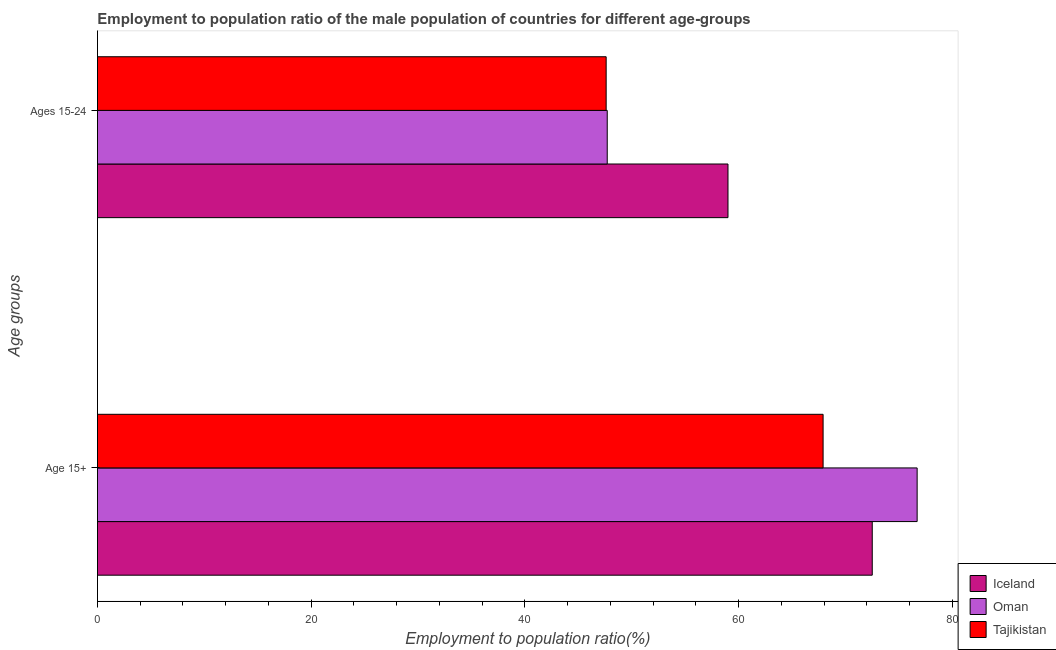How many groups of bars are there?
Offer a terse response. 2. How many bars are there on the 2nd tick from the top?
Give a very brief answer. 3. What is the label of the 2nd group of bars from the top?
Your answer should be compact. Age 15+. What is the employment to population ratio(age 15+) in Oman?
Give a very brief answer. 76.7. Across all countries, what is the minimum employment to population ratio(age 15-24)?
Offer a very short reply. 47.6. In which country was the employment to population ratio(age 15-24) maximum?
Your answer should be compact. Iceland. In which country was the employment to population ratio(age 15-24) minimum?
Make the answer very short. Tajikistan. What is the total employment to population ratio(age 15+) in the graph?
Provide a succinct answer. 217.1. What is the difference between the employment to population ratio(age 15-24) in Oman and that in Tajikistan?
Make the answer very short. 0.1. What is the difference between the employment to population ratio(age 15-24) in Tajikistan and the employment to population ratio(age 15+) in Iceland?
Give a very brief answer. -24.9. What is the average employment to population ratio(age 15+) per country?
Offer a terse response. 72.37. What is the difference between the employment to population ratio(age 15-24) and employment to population ratio(age 15+) in Oman?
Provide a short and direct response. -29. In how many countries, is the employment to population ratio(age 15-24) greater than 4 %?
Keep it short and to the point. 3. What is the ratio of the employment to population ratio(age 15-24) in Oman to that in Iceland?
Ensure brevity in your answer.  0.81. Is the employment to population ratio(age 15-24) in Iceland less than that in Tajikistan?
Offer a very short reply. No. In how many countries, is the employment to population ratio(age 15-24) greater than the average employment to population ratio(age 15-24) taken over all countries?
Offer a very short reply. 1. What does the 2nd bar from the top in Ages 15-24 represents?
Keep it short and to the point. Oman. What does the 3rd bar from the bottom in Ages 15-24 represents?
Make the answer very short. Tajikistan. How many bars are there?
Offer a very short reply. 6. Are all the bars in the graph horizontal?
Your answer should be compact. Yes. How many countries are there in the graph?
Keep it short and to the point. 3. Does the graph contain any zero values?
Make the answer very short. No. Does the graph contain grids?
Your answer should be compact. No. Where does the legend appear in the graph?
Offer a terse response. Bottom right. How are the legend labels stacked?
Make the answer very short. Vertical. What is the title of the graph?
Give a very brief answer. Employment to population ratio of the male population of countries for different age-groups. Does "Mexico" appear as one of the legend labels in the graph?
Your response must be concise. No. What is the label or title of the Y-axis?
Your answer should be compact. Age groups. What is the Employment to population ratio(%) in Iceland in Age 15+?
Ensure brevity in your answer.  72.5. What is the Employment to population ratio(%) in Oman in Age 15+?
Keep it short and to the point. 76.7. What is the Employment to population ratio(%) in Tajikistan in Age 15+?
Offer a very short reply. 67.9. What is the Employment to population ratio(%) of Oman in Ages 15-24?
Your answer should be compact. 47.7. What is the Employment to population ratio(%) of Tajikistan in Ages 15-24?
Your response must be concise. 47.6. Across all Age groups, what is the maximum Employment to population ratio(%) of Iceland?
Your answer should be compact. 72.5. Across all Age groups, what is the maximum Employment to population ratio(%) in Oman?
Your answer should be compact. 76.7. Across all Age groups, what is the maximum Employment to population ratio(%) in Tajikistan?
Your answer should be compact. 67.9. Across all Age groups, what is the minimum Employment to population ratio(%) of Oman?
Provide a succinct answer. 47.7. Across all Age groups, what is the minimum Employment to population ratio(%) of Tajikistan?
Your answer should be compact. 47.6. What is the total Employment to population ratio(%) of Iceland in the graph?
Provide a short and direct response. 131.5. What is the total Employment to population ratio(%) in Oman in the graph?
Offer a terse response. 124.4. What is the total Employment to population ratio(%) of Tajikistan in the graph?
Offer a terse response. 115.5. What is the difference between the Employment to population ratio(%) of Oman in Age 15+ and that in Ages 15-24?
Your answer should be very brief. 29. What is the difference between the Employment to population ratio(%) in Tajikistan in Age 15+ and that in Ages 15-24?
Provide a short and direct response. 20.3. What is the difference between the Employment to population ratio(%) in Iceland in Age 15+ and the Employment to population ratio(%) in Oman in Ages 15-24?
Make the answer very short. 24.8. What is the difference between the Employment to population ratio(%) of Iceland in Age 15+ and the Employment to population ratio(%) of Tajikistan in Ages 15-24?
Ensure brevity in your answer.  24.9. What is the difference between the Employment to population ratio(%) of Oman in Age 15+ and the Employment to population ratio(%) of Tajikistan in Ages 15-24?
Offer a very short reply. 29.1. What is the average Employment to population ratio(%) of Iceland per Age groups?
Your response must be concise. 65.75. What is the average Employment to population ratio(%) of Oman per Age groups?
Your response must be concise. 62.2. What is the average Employment to population ratio(%) in Tajikistan per Age groups?
Your answer should be compact. 57.75. What is the difference between the Employment to population ratio(%) in Iceland and Employment to population ratio(%) in Oman in Age 15+?
Provide a succinct answer. -4.2. What is the difference between the Employment to population ratio(%) in Iceland and Employment to population ratio(%) in Tajikistan in Age 15+?
Provide a short and direct response. 4.6. What is the difference between the Employment to population ratio(%) of Iceland and Employment to population ratio(%) of Oman in Ages 15-24?
Offer a very short reply. 11.3. What is the difference between the Employment to population ratio(%) of Iceland and Employment to population ratio(%) of Tajikistan in Ages 15-24?
Offer a terse response. 11.4. What is the difference between the Employment to population ratio(%) in Oman and Employment to population ratio(%) in Tajikistan in Ages 15-24?
Provide a short and direct response. 0.1. What is the ratio of the Employment to population ratio(%) in Iceland in Age 15+ to that in Ages 15-24?
Your answer should be very brief. 1.23. What is the ratio of the Employment to population ratio(%) in Oman in Age 15+ to that in Ages 15-24?
Give a very brief answer. 1.61. What is the ratio of the Employment to population ratio(%) in Tajikistan in Age 15+ to that in Ages 15-24?
Give a very brief answer. 1.43. What is the difference between the highest and the second highest Employment to population ratio(%) of Iceland?
Make the answer very short. 13.5. What is the difference between the highest and the second highest Employment to population ratio(%) of Tajikistan?
Your response must be concise. 20.3. What is the difference between the highest and the lowest Employment to population ratio(%) in Iceland?
Make the answer very short. 13.5. What is the difference between the highest and the lowest Employment to population ratio(%) of Oman?
Offer a very short reply. 29. What is the difference between the highest and the lowest Employment to population ratio(%) in Tajikistan?
Offer a terse response. 20.3. 